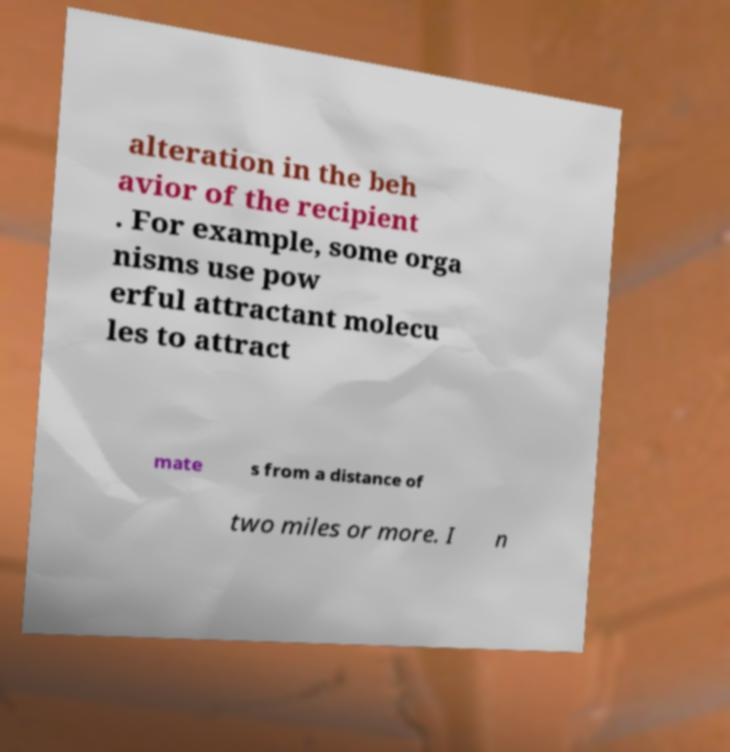I need the written content from this picture converted into text. Can you do that? alteration in the beh avior of the recipient . For example, some orga nisms use pow erful attractant molecu les to attract mate s from a distance of two miles or more. I n 